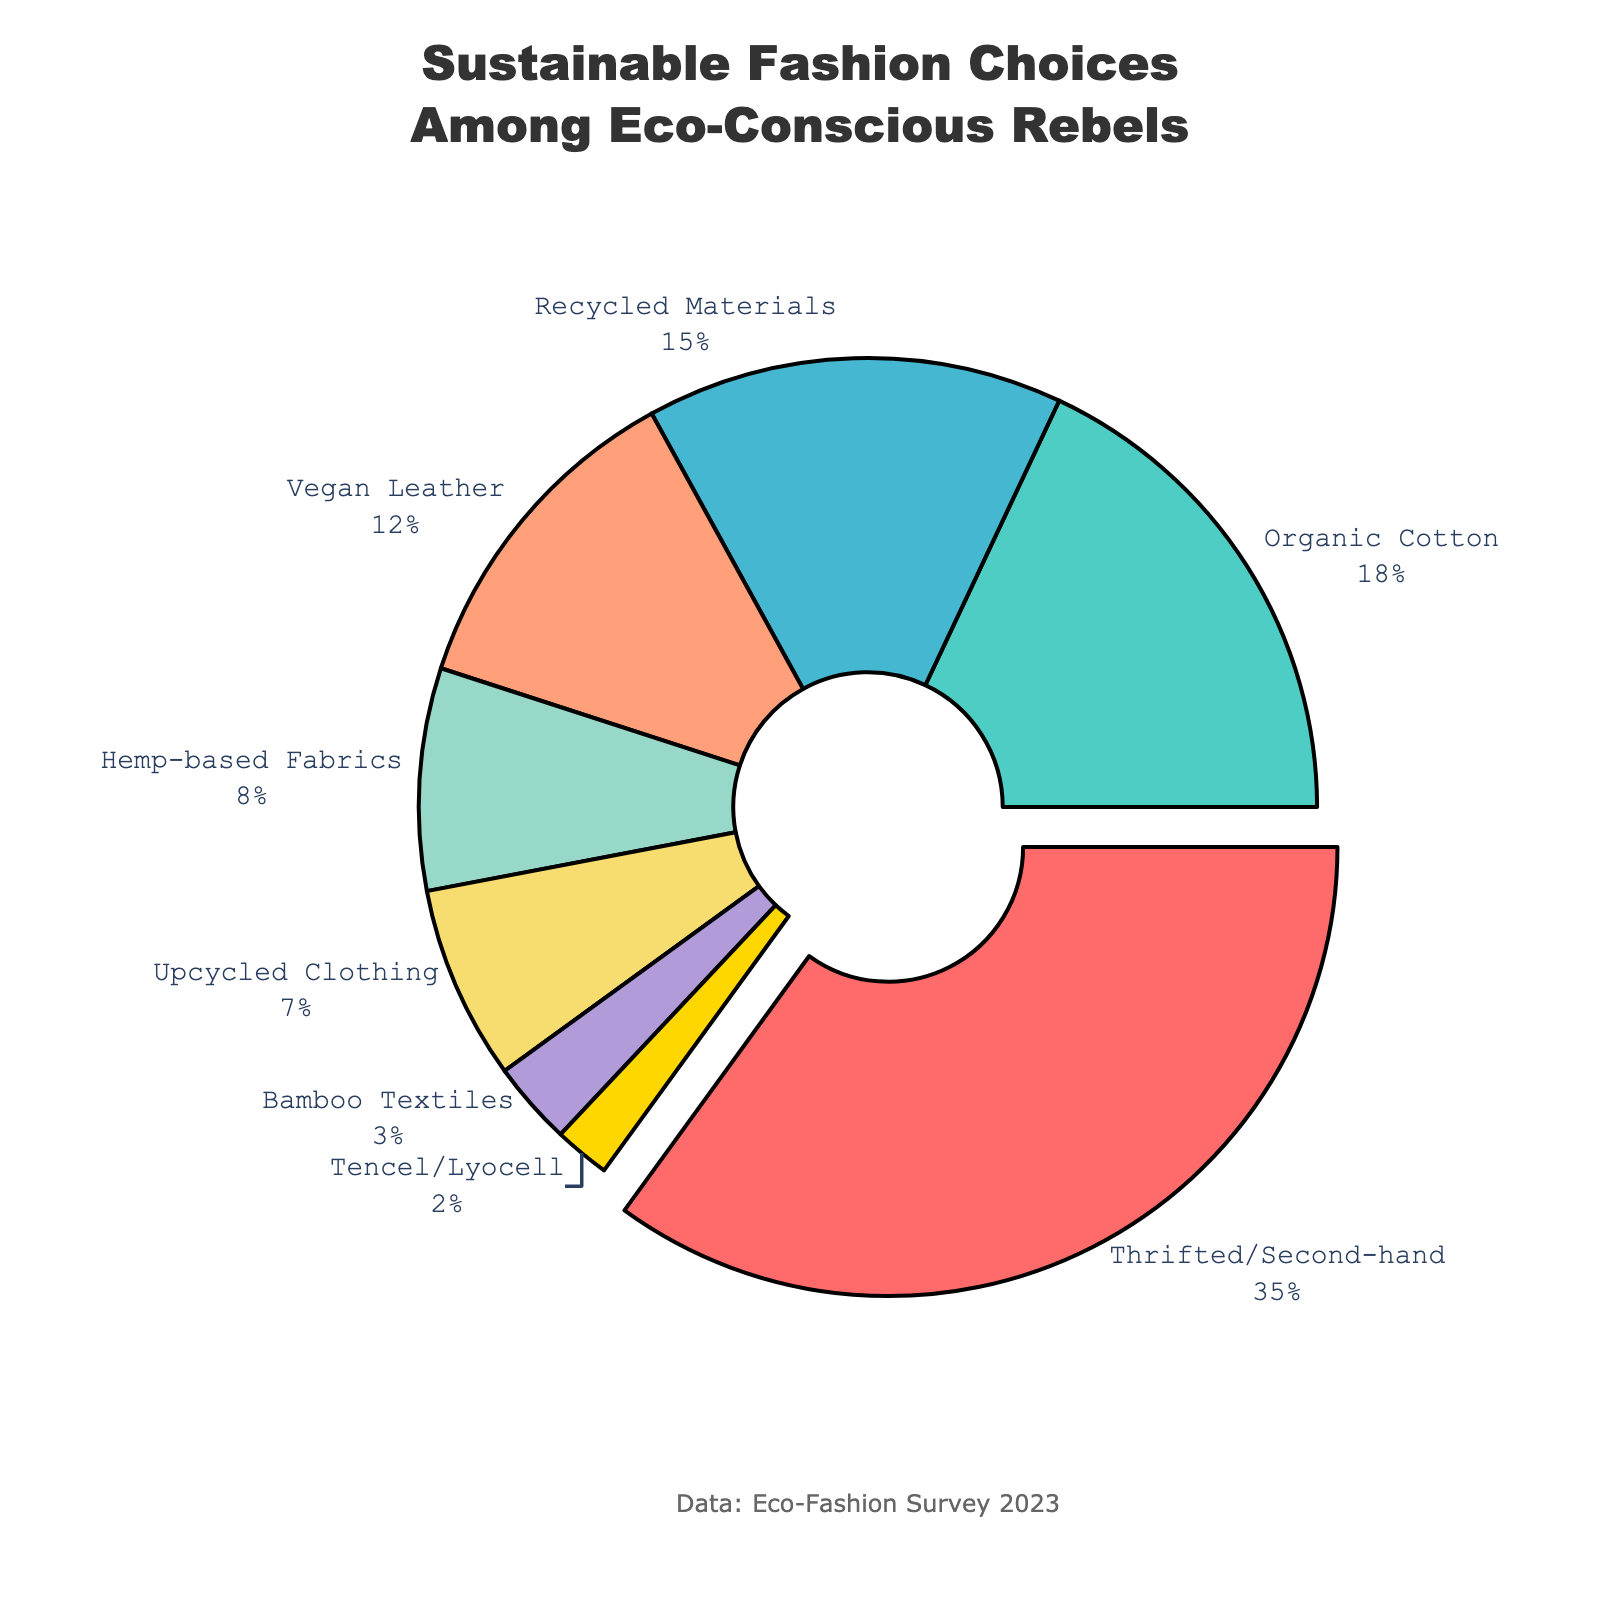what category holds the largest share among sustainable fashion choices? The largest segment in the pie chart is highlighted, and its label shows it's "Thrifted/Second-hand" with 35%.
Answer: Thrifted/Second-hand Which categories together make up more than half of the eco-conscious consumers' choices? By adding up the percentages of the categories: Thrifted/Second-hand (35%), Organic Cotton (18%), Recycled Materials (15%), and Vegan Leather (12%) gives a total of 80%, which is more than half (50%). So these categories together make up more than half.
Answer: Thrifted/Second-hand, Organic Cotton, Recycled Materials, Vegan Leather How does the share of Upcycled Clothing compare to that of Hemp-based Fabrics? We look at the percentage of Upcycled Clothing (7%) and compare it to Hemp-based Fabrics (8%). Upcycled Clothing is 1% less than Hemp-based Fabrics.
Answer: Upcycled Clothing is 1% less than Hemp-based Fabrics Which category has the smallest percentage, and what is its value? The category with the smallest slice of the pie chart is "Tencel/Lyocell" at 2%.
Answer: Tencel/Lyocell, 2% What is the combined percentage of categories that are less than 10% each? Adding the percentages of Hemp-based Fabrics (8%), Upcycled Clothing (7%), Bamboo Textiles (3%), and Tencel/Lyocell (2%) results in a combined total of 20%.
Answer: 20% Which category represents the highest percentage of choices, and what visual feature makes it stand out in the pie chart? The category "Thrifted/Second-hand" represents the highest percentage (35%) and stands out because it is pulled away from the center of the pie chart.
Answer: Thrifted/Second-hand, pulled away from the center How does the proportion of choices for Organic Cotton compare to that for Recycled Materials? Organic Cotton accounts for 18% and Recycled Materials for 15%. Organic Cotton's proportion is 3% higher than Recycled Materials.
Answer: Organic Cotton is 3% higher than Recycled Materials Identify the categories that together account for less than 5%. Only "Tencel/Lyocell" falls into this range with 2%.
Answer: Tencel/Lyocell What percentage of consumers prefer materials derived from plants (Hemp-based Fabrics and Bamboo Textiles together)? Summing up the percentages of Hemp-based Fabrics (8%) and Bamboo Textiles (3%) gives a total of 11%.
Answer: 11% What percentage of sustainable fashion choices is made up of non-organic materials (exclude Thrifted/Second-hand and Organic Cotton)? Subtracting the percentages for Thrifted/Second-hand (35%) and Organic Cotton (18%) from 100% results in 47%.
Answer: 47% 